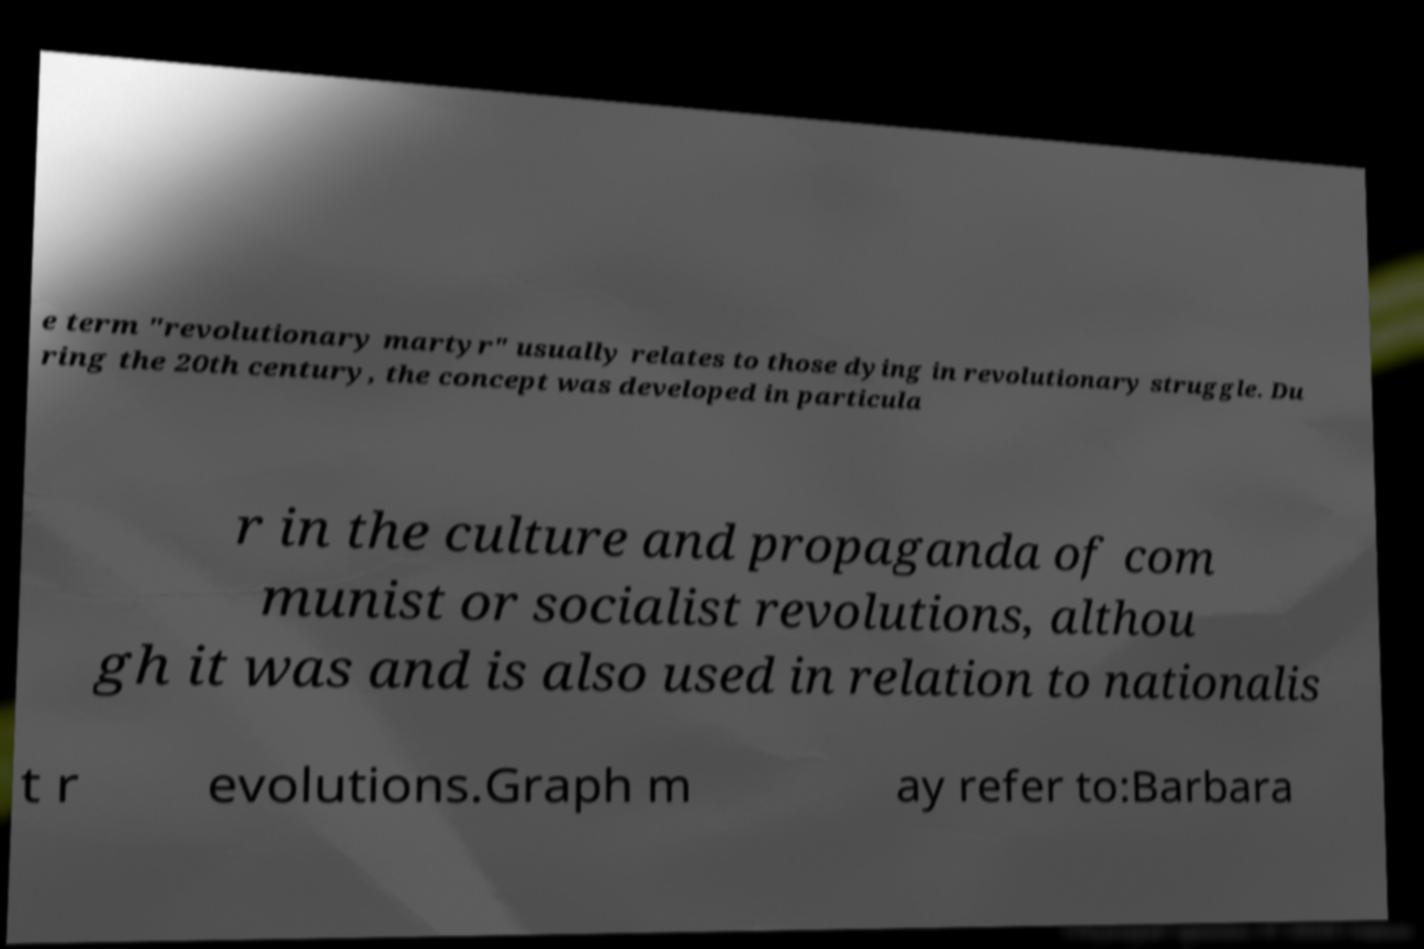What messages or text are displayed in this image? I need them in a readable, typed format. e term "revolutionary martyr" usually relates to those dying in revolutionary struggle. Du ring the 20th century, the concept was developed in particula r in the culture and propaganda of com munist or socialist revolutions, althou gh it was and is also used in relation to nationalis t r evolutions.Graph m ay refer to:Barbara 